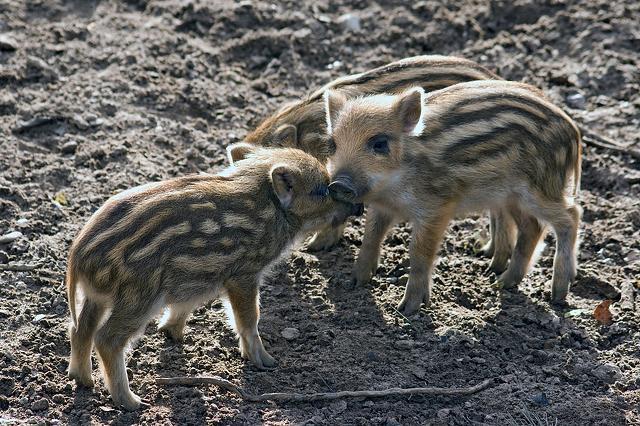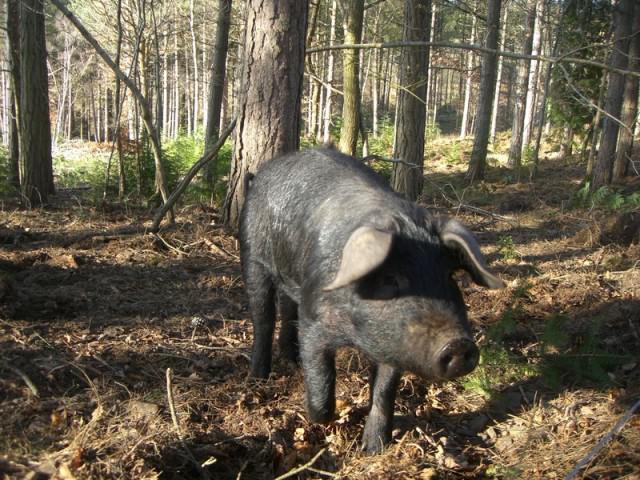The first image is the image on the left, the second image is the image on the right. For the images displayed, is the sentence "The left image contains no more than three wild boars." factually correct? Answer yes or no. Yes. The first image is the image on the left, the second image is the image on the right. Analyze the images presented: Is the assertion "There are two hogs with at least one baby in the image." valid? Answer yes or no. No. 